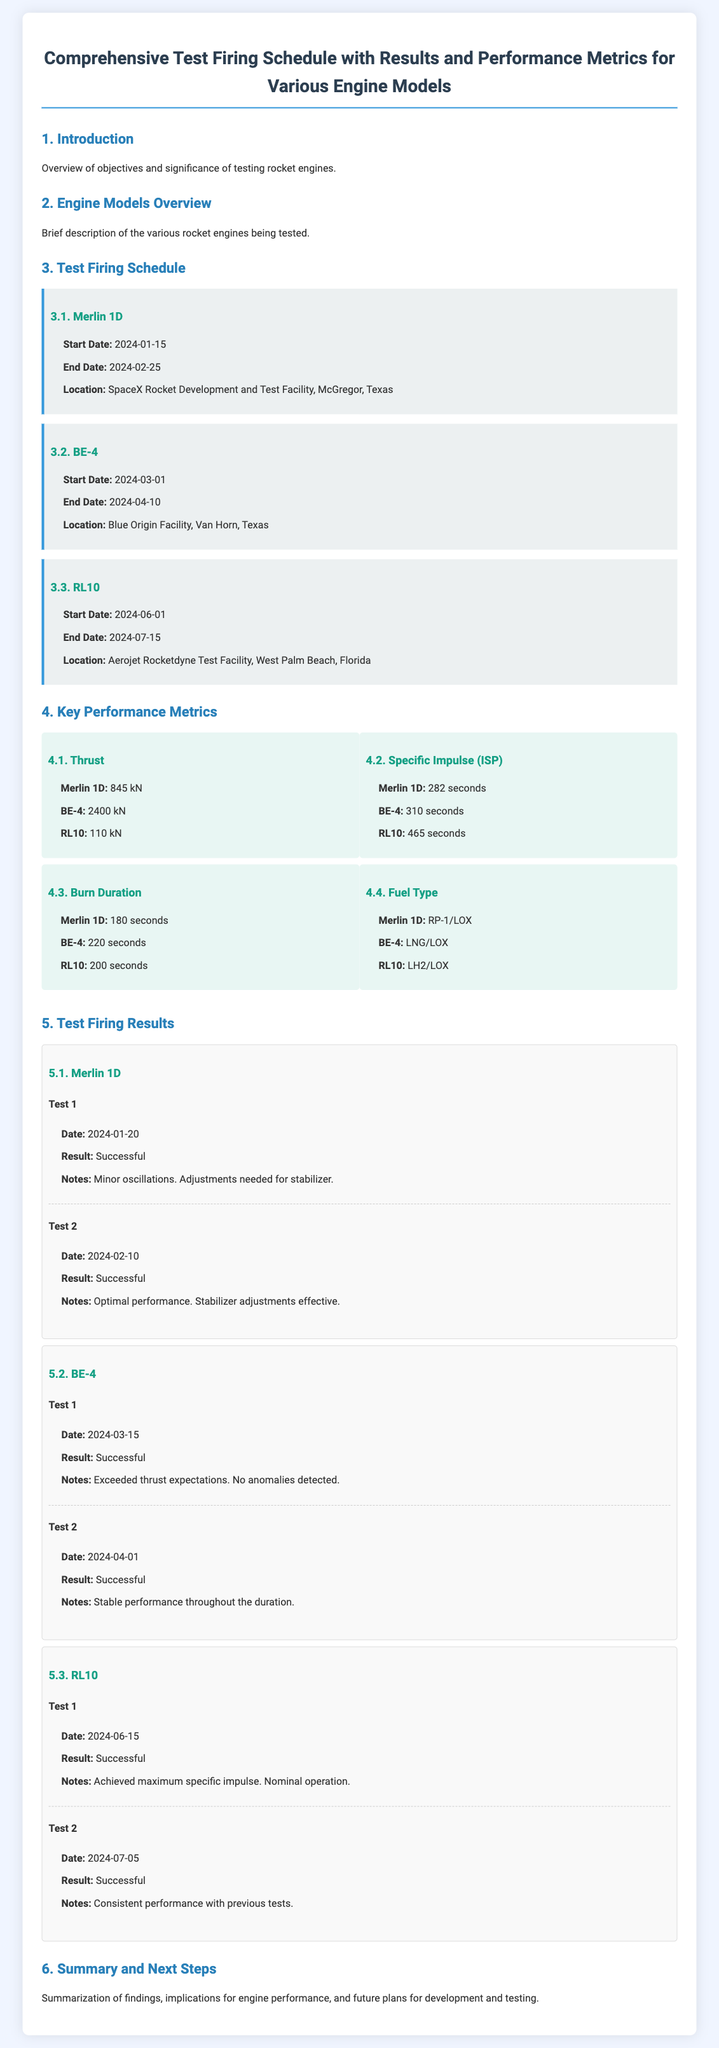What is the start date for Merlin 1D? The start date for Merlin 1D is specified in the Test Firing Schedule section of the document.
Answer: 2024-01-15 What is the thrust of BE-4? The thrust of BE-4 is listed under the Key Performance Metrics section.
Answer: 2400 kN How long is the burn duration for RL10? The burn duration for RL10 can be found in the Key Performance Metrics section.
Answer: 200 seconds What significant notes were made during the first test of Merlin 1D? The notes from the first test are documented in the Test Firing Results section.
Answer: Minor oscillations. Adjustments needed for stabilizer Which facility will the BE-4 test firing occur? The location of the BE-4 test firing is mentioned in the Test Firing Schedule section.
Answer: Blue Origin Facility, Van Horn, Texas What is the result of the first test for RL10? The results of the first test for RL10 are summarized in the Test Firing Results section.
Answer: Successful What metric for Merlin 1D indicates its fuel type? The fuel type for Merlin 1D is categorized under the Key Performance Metrics section.
Answer: RP-1/LOX On which date was the second test of BE-4 conducted? The date of the second test for BE-4 can be found in the Test Firing Results section.
Answer: 2024-04-01 What is the maximum specific impulse achieved in the first test of RL10? The specifics about the maximum specific impulse for RL10 during its first test are described in the Test Firing Results section.
Answer: Achieved maximum specific impulse 